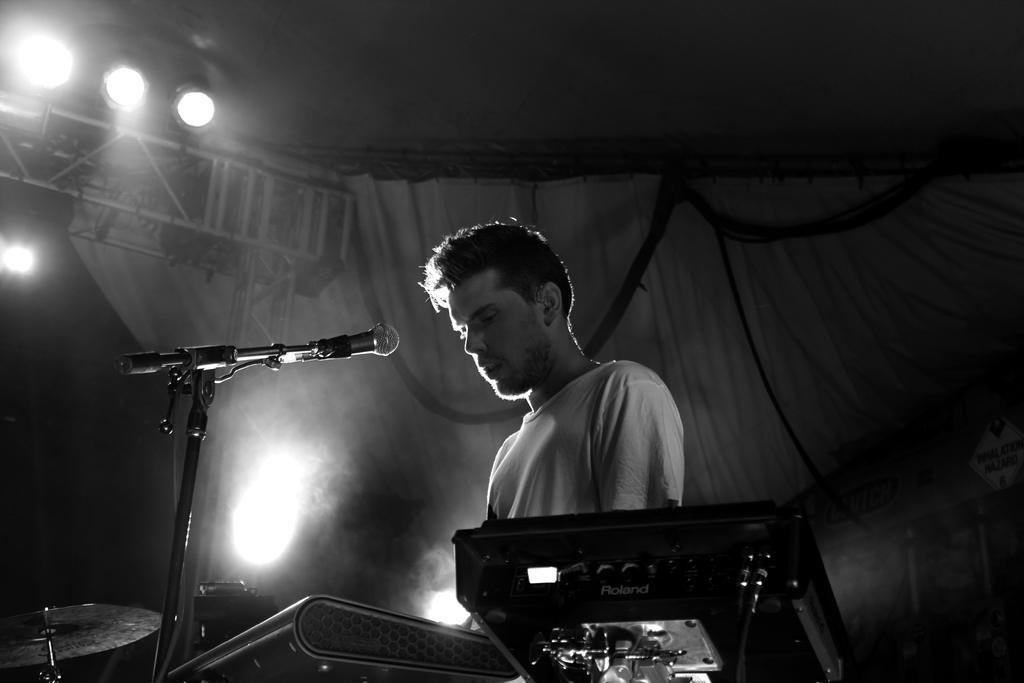Please provide a concise description of this image. This is a black and white picture, In the middle there is a man with mic and music instruments in front of him and over the ceiling there are lights and over the background there is curtain. 